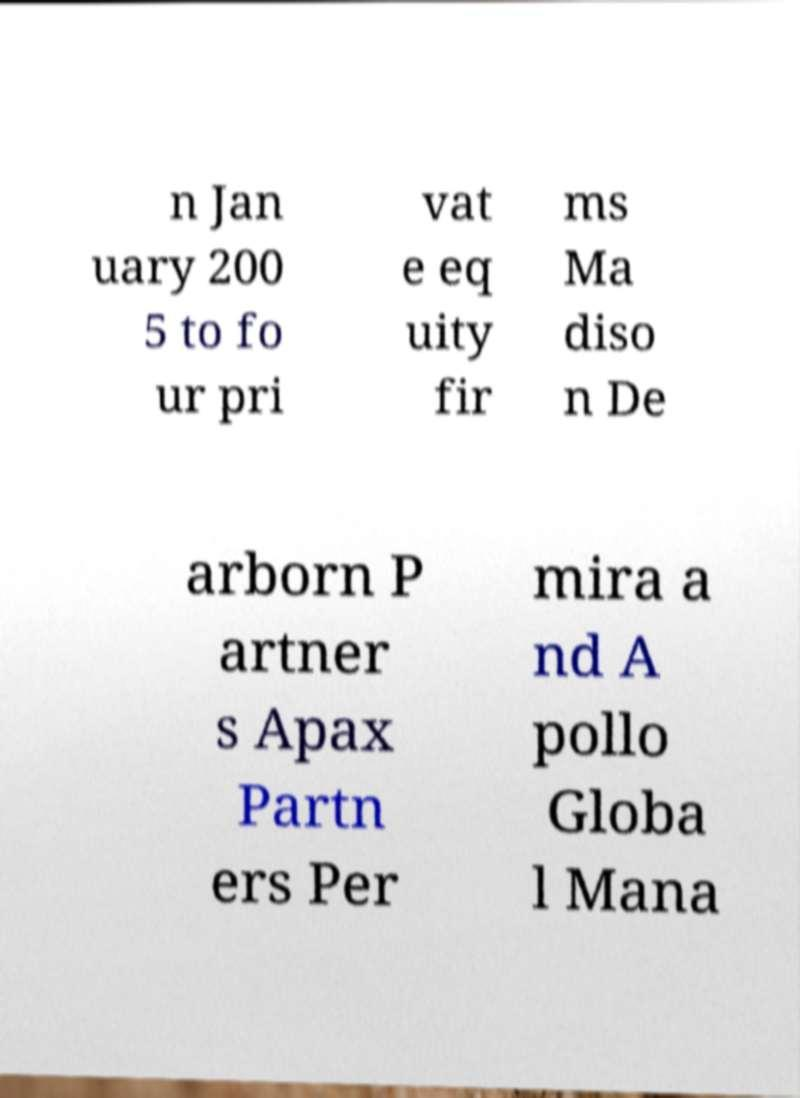Please identify and transcribe the text found in this image. n Jan uary 200 5 to fo ur pri vat e eq uity fir ms Ma diso n De arborn P artner s Apax Partn ers Per mira a nd A pollo Globa l Mana 